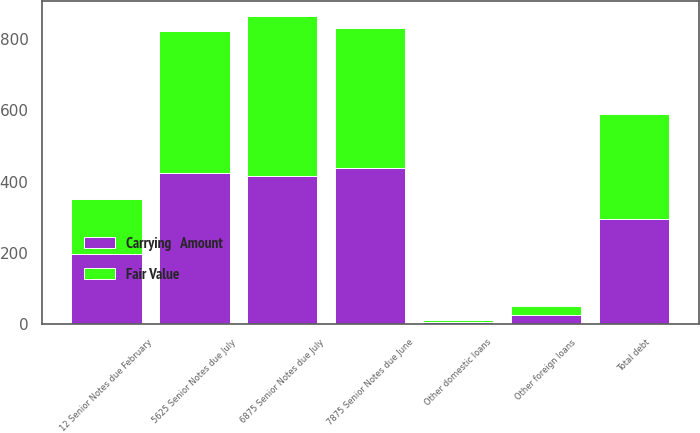Convert chart to OTSL. <chart><loc_0><loc_0><loc_500><loc_500><stacked_bar_chart><ecel><fcel>5625 Senior Notes due July<fcel>12 Senior Notes due February<fcel>7875 Senior Notes due June<fcel>6875 Senior Notes due July<fcel>Other foreign loans<fcel>Other domestic loans<fcel>Total debt<nl><fcel>Fair Value<fcel>399.4<fcel>156<fcel>392.6<fcel>448.5<fcel>26.2<fcel>6.5<fcel>294.55<nl><fcel>Carrying   Amount<fcel>423.1<fcel>196.5<fcel>438.8<fcel>415.1<fcel>26<fcel>6.5<fcel>294.55<nl></chart> 